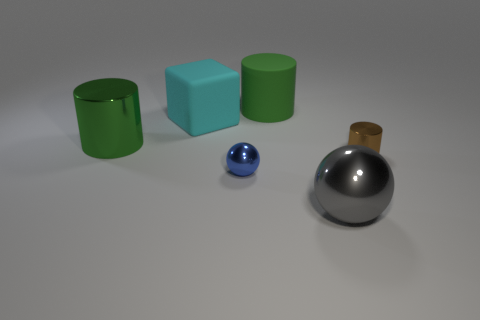The other cylinder that is made of the same material as the small cylinder is what size?
Give a very brief answer. Large. How many red objects are large cylinders or cylinders?
Your answer should be very brief. 0. How many matte cylinders are behind the big object that is in front of the green shiny cylinder?
Your answer should be very brief. 1. Is the number of small blue metallic spheres on the left side of the cyan block greater than the number of big green metallic objects that are in front of the tiny blue thing?
Your response must be concise. No. What is the cube made of?
Offer a very short reply. Rubber. Are there any brown cylinders that have the same size as the blue shiny object?
Your answer should be compact. Yes. What is the material of the brown object that is the same size as the blue metal object?
Your answer should be compact. Metal. How many big cyan rubber blocks are there?
Your response must be concise. 1. There is a ball left of the large gray thing; what is its size?
Give a very brief answer. Small. Is the number of cyan cubes that are in front of the large matte block the same as the number of small gray balls?
Provide a succinct answer. Yes. 